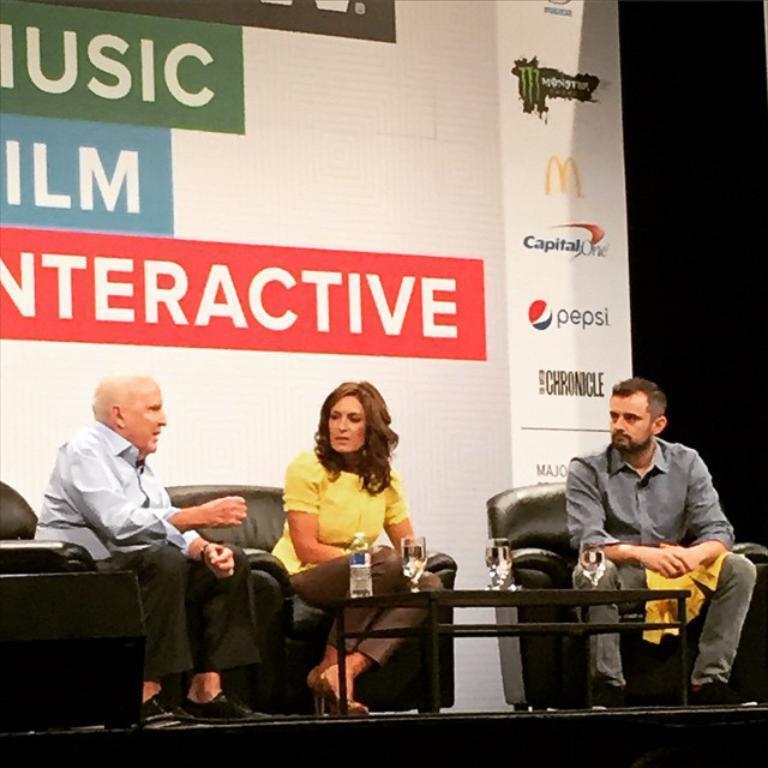Could you give a brief overview of what you see in this image? In the center of the image there are three people sitting on the sofa. There is a table placed before them. We can see glasses, bottle placed on the table. In the background there is a board. 